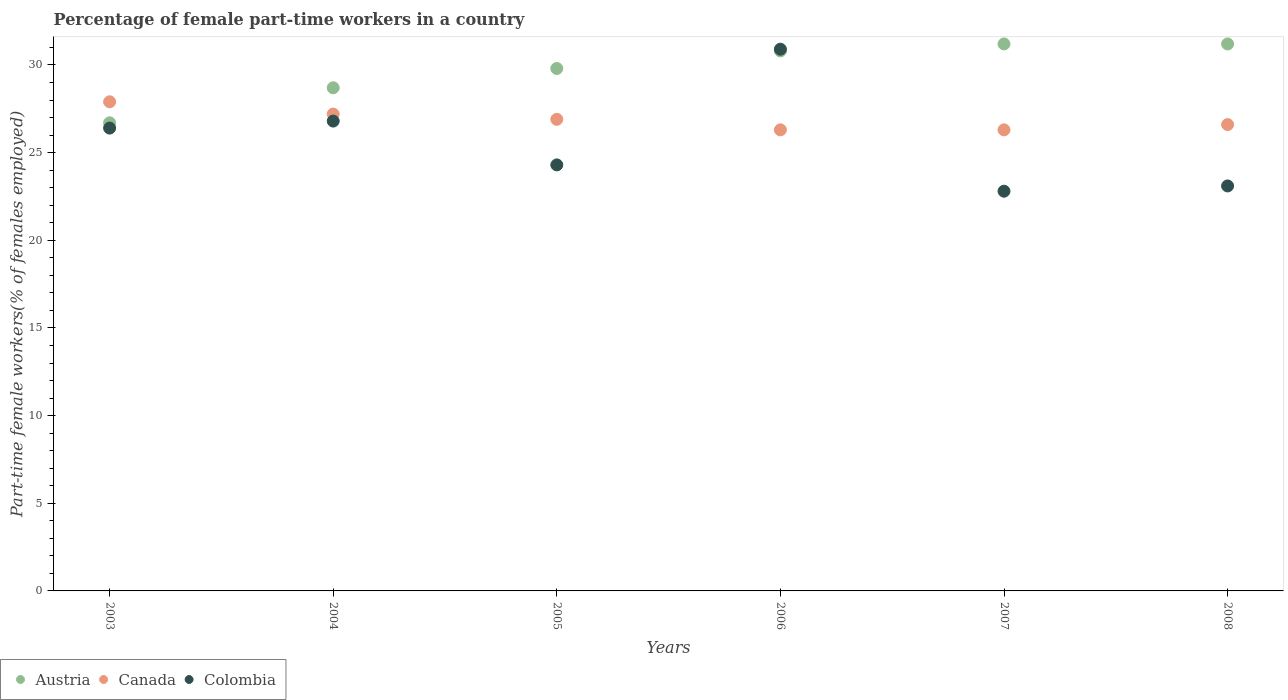How many different coloured dotlines are there?
Your response must be concise. 3. Is the number of dotlines equal to the number of legend labels?
Offer a very short reply. Yes. What is the percentage of female part-time workers in Canada in 2008?
Ensure brevity in your answer.  26.6. Across all years, what is the maximum percentage of female part-time workers in Colombia?
Offer a terse response. 30.9. Across all years, what is the minimum percentage of female part-time workers in Canada?
Give a very brief answer. 26.3. In which year was the percentage of female part-time workers in Canada maximum?
Provide a succinct answer. 2003. In which year was the percentage of female part-time workers in Canada minimum?
Provide a succinct answer. 2006. What is the total percentage of female part-time workers in Canada in the graph?
Give a very brief answer. 161.2. What is the difference between the percentage of female part-time workers in Austria in 2007 and that in 2008?
Give a very brief answer. 0. What is the difference between the percentage of female part-time workers in Austria in 2003 and the percentage of female part-time workers in Colombia in 2005?
Offer a terse response. 2.4. What is the average percentage of female part-time workers in Canada per year?
Provide a short and direct response. 26.87. In the year 2003, what is the difference between the percentage of female part-time workers in Canada and percentage of female part-time workers in Austria?
Keep it short and to the point. 1.2. What is the ratio of the percentage of female part-time workers in Colombia in 2004 to that in 2008?
Make the answer very short. 1.16. What is the difference between the highest and the second highest percentage of female part-time workers in Austria?
Give a very brief answer. 0. What is the difference between the highest and the lowest percentage of female part-time workers in Canada?
Provide a short and direct response. 1.6. In how many years, is the percentage of female part-time workers in Colombia greater than the average percentage of female part-time workers in Colombia taken over all years?
Ensure brevity in your answer.  3. How many dotlines are there?
Your answer should be very brief. 3. What is the difference between two consecutive major ticks on the Y-axis?
Provide a short and direct response. 5. Are the values on the major ticks of Y-axis written in scientific E-notation?
Offer a very short reply. No. What is the title of the graph?
Your answer should be compact. Percentage of female part-time workers in a country. What is the label or title of the Y-axis?
Provide a short and direct response. Part-time female workers(% of females employed). What is the Part-time female workers(% of females employed) of Austria in 2003?
Give a very brief answer. 26.7. What is the Part-time female workers(% of females employed) in Canada in 2003?
Keep it short and to the point. 27.9. What is the Part-time female workers(% of females employed) in Colombia in 2003?
Offer a terse response. 26.4. What is the Part-time female workers(% of females employed) in Austria in 2004?
Offer a very short reply. 28.7. What is the Part-time female workers(% of females employed) of Canada in 2004?
Your answer should be compact. 27.2. What is the Part-time female workers(% of females employed) of Colombia in 2004?
Offer a very short reply. 26.8. What is the Part-time female workers(% of females employed) of Austria in 2005?
Offer a terse response. 29.8. What is the Part-time female workers(% of females employed) in Canada in 2005?
Your answer should be very brief. 26.9. What is the Part-time female workers(% of females employed) in Colombia in 2005?
Your answer should be compact. 24.3. What is the Part-time female workers(% of females employed) of Austria in 2006?
Give a very brief answer. 30.8. What is the Part-time female workers(% of females employed) in Canada in 2006?
Provide a short and direct response. 26.3. What is the Part-time female workers(% of females employed) of Colombia in 2006?
Make the answer very short. 30.9. What is the Part-time female workers(% of females employed) of Austria in 2007?
Your answer should be compact. 31.2. What is the Part-time female workers(% of females employed) of Canada in 2007?
Your answer should be very brief. 26.3. What is the Part-time female workers(% of females employed) in Colombia in 2007?
Provide a succinct answer. 22.8. What is the Part-time female workers(% of females employed) in Austria in 2008?
Offer a very short reply. 31.2. What is the Part-time female workers(% of females employed) of Canada in 2008?
Provide a short and direct response. 26.6. What is the Part-time female workers(% of females employed) in Colombia in 2008?
Make the answer very short. 23.1. Across all years, what is the maximum Part-time female workers(% of females employed) in Austria?
Provide a succinct answer. 31.2. Across all years, what is the maximum Part-time female workers(% of females employed) of Canada?
Keep it short and to the point. 27.9. Across all years, what is the maximum Part-time female workers(% of females employed) of Colombia?
Provide a succinct answer. 30.9. Across all years, what is the minimum Part-time female workers(% of females employed) in Austria?
Your answer should be very brief. 26.7. Across all years, what is the minimum Part-time female workers(% of females employed) of Canada?
Your answer should be compact. 26.3. Across all years, what is the minimum Part-time female workers(% of females employed) of Colombia?
Provide a short and direct response. 22.8. What is the total Part-time female workers(% of females employed) of Austria in the graph?
Provide a short and direct response. 178.4. What is the total Part-time female workers(% of females employed) of Canada in the graph?
Provide a short and direct response. 161.2. What is the total Part-time female workers(% of females employed) of Colombia in the graph?
Your response must be concise. 154.3. What is the difference between the Part-time female workers(% of females employed) of Colombia in 2003 and that in 2004?
Your answer should be very brief. -0.4. What is the difference between the Part-time female workers(% of females employed) of Canada in 2003 and that in 2005?
Provide a succinct answer. 1. What is the difference between the Part-time female workers(% of females employed) of Colombia in 2003 and that in 2005?
Keep it short and to the point. 2.1. What is the difference between the Part-time female workers(% of females employed) in Austria in 2003 and that in 2006?
Your answer should be very brief. -4.1. What is the difference between the Part-time female workers(% of females employed) of Canada in 2003 and that in 2006?
Provide a succinct answer. 1.6. What is the difference between the Part-time female workers(% of females employed) in Colombia in 2003 and that in 2006?
Offer a terse response. -4.5. What is the difference between the Part-time female workers(% of females employed) in Austria in 2003 and that in 2007?
Keep it short and to the point. -4.5. What is the difference between the Part-time female workers(% of females employed) of Colombia in 2003 and that in 2007?
Your answer should be very brief. 3.6. What is the difference between the Part-time female workers(% of females employed) of Canada in 2003 and that in 2008?
Your answer should be compact. 1.3. What is the difference between the Part-time female workers(% of females employed) in Colombia in 2003 and that in 2008?
Offer a very short reply. 3.3. What is the difference between the Part-time female workers(% of females employed) in Austria in 2004 and that in 2005?
Offer a very short reply. -1.1. What is the difference between the Part-time female workers(% of females employed) in Colombia in 2004 and that in 2005?
Your answer should be very brief. 2.5. What is the difference between the Part-time female workers(% of females employed) of Colombia in 2004 and that in 2006?
Your answer should be very brief. -4.1. What is the difference between the Part-time female workers(% of females employed) in Canada in 2004 and that in 2007?
Your response must be concise. 0.9. What is the difference between the Part-time female workers(% of females employed) of Austria in 2004 and that in 2008?
Your response must be concise. -2.5. What is the difference between the Part-time female workers(% of females employed) of Colombia in 2004 and that in 2008?
Ensure brevity in your answer.  3.7. What is the difference between the Part-time female workers(% of females employed) in Canada in 2005 and that in 2006?
Offer a terse response. 0.6. What is the difference between the Part-time female workers(% of females employed) of Colombia in 2005 and that in 2006?
Keep it short and to the point. -6.6. What is the difference between the Part-time female workers(% of females employed) in Austria in 2005 and that in 2007?
Ensure brevity in your answer.  -1.4. What is the difference between the Part-time female workers(% of females employed) in Colombia in 2005 and that in 2007?
Your answer should be compact. 1.5. What is the difference between the Part-time female workers(% of females employed) of Austria in 2005 and that in 2008?
Provide a succinct answer. -1.4. What is the difference between the Part-time female workers(% of females employed) in Colombia in 2005 and that in 2008?
Your answer should be compact. 1.2. What is the difference between the Part-time female workers(% of females employed) of Canada in 2006 and that in 2008?
Offer a very short reply. -0.3. What is the difference between the Part-time female workers(% of females employed) of Colombia in 2006 and that in 2008?
Your answer should be compact. 7.8. What is the difference between the Part-time female workers(% of females employed) of Austria in 2007 and that in 2008?
Offer a very short reply. 0. What is the difference between the Part-time female workers(% of females employed) of Canada in 2007 and that in 2008?
Your response must be concise. -0.3. What is the difference between the Part-time female workers(% of females employed) in Colombia in 2007 and that in 2008?
Keep it short and to the point. -0.3. What is the difference between the Part-time female workers(% of females employed) in Austria in 2003 and the Part-time female workers(% of females employed) in Canada in 2004?
Provide a short and direct response. -0.5. What is the difference between the Part-time female workers(% of females employed) in Canada in 2003 and the Part-time female workers(% of females employed) in Colombia in 2004?
Make the answer very short. 1.1. What is the difference between the Part-time female workers(% of females employed) in Austria in 2003 and the Part-time female workers(% of females employed) in Canada in 2005?
Keep it short and to the point. -0.2. What is the difference between the Part-time female workers(% of females employed) of Austria in 2003 and the Part-time female workers(% of females employed) of Colombia in 2005?
Your answer should be very brief. 2.4. What is the difference between the Part-time female workers(% of females employed) of Canada in 2003 and the Part-time female workers(% of females employed) of Colombia in 2005?
Your answer should be compact. 3.6. What is the difference between the Part-time female workers(% of females employed) of Austria in 2003 and the Part-time female workers(% of females employed) of Canada in 2006?
Offer a terse response. 0.4. What is the difference between the Part-time female workers(% of females employed) of Austria in 2003 and the Part-time female workers(% of females employed) of Canada in 2008?
Offer a terse response. 0.1. What is the difference between the Part-time female workers(% of females employed) of Austria in 2003 and the Part-time female workers(% of females employed) of Colombia in 2008?
Provide a short and direct response. 3.6. What is the difference between the Part-time female workers(% of females employed) of Austria in 2004 and the Part-time female workers(% of females employed) of Canada in 2005?
Your answer should be very brief. 1.8. What is the difference between the Part-time female workers(% of females employed) in Canada in 2004 and the Part-time female workers(% of females employed) in Colombia in 2006?
Keep it short and to the point. -3.7. What is the difference between the Part-time female workers(% of females employed) of Austria in 2004 and the Part-time female workers(% of females employed) of Colombia in 2007?
Provide a short and direct response. 5.9. What is the difference between the Part-time female workers(% of females employed) in Austria in 2005 and the Part-time female workers(% of females employed) in Colombia in 2006?
Give a very brief answer. -1.1. What is the difference between the Part-time female workers(% of females employed) of Canada in 2005 and the Part-time female workers(% of females employed) of Colombia in 2006?
Make the answer very short. -4. What is the difference between the Part-time female workers(% of females employed) in Austria in 2005 and the Part-time female workers(% of females employed) in Colombia in 2007?
Your answer should be compact. 7. What is the difference between the Part-time female workers(% of females employed) in Austria in 2005 and the Part-time female workers(% of females employed) in Canada in 2008?
Offer a very short reply. 3.2. What is the difference between the Part-time female workers(% of females employed) in Austria in 2005 and the Part-time female workers(% of females employed) in Colombia in 2008?
Ensure brevity in your answer.  6.7. What is the difference between the Part-time female workers(% of females employed) in Canada in 2005 and the Part-time female workers(% of females employed) in Colombia in 2008?
Keep it short and to the point. 3.8. What is the difference between the Part-time female workers(% of females employed) of Canada in 2006 and the Part-time female workers(% of females employed) of Colombia in 2007?
Keep it short and to the point. 3.5. What is the difference between the Part-time female workers(% of females employed) of Austria in 2006 and the Part-time female workers(% of females employed) of Colombia in 2008?
Ensure brevity in your answer.  7.7. What is the average Part-time female workers(% of females employed) in Austria per year?
Provide a short and direct response. 29.73. What is the average Part-time female workers(% of females employed) of Canada per year?
Give a very brief answer. 26.87. What is the average Part-time female workers(% of females employed) in Colombia per year?
Offer a very short reply. 25.72. In the year 2003, what is the difference between the Part-time female workers(% of females employed) in Austria and Part-time female workers(% of females employed) in Canada?
Provide a short and direct response. -1.2. In the year 2004, what is the difference between the Part-time female workers(% of females employed) of Austria and Part-time female workers(% of females employed) of Canada?
Keep it short and to the point. 1.5. In the year 2004, what is the difference between the Part-time female workers(% of females employed) of Austria and Part-time female workers(% of females employed) of Colombia?
Give a very brief answer. 1.9. In the year 2005, what is the difference between the Part-time female workers(% of females employed) of Austria and Part-time female workers(% of females employed) of Canada?
Make the answer very short. 2.9. In the year 2005, what is the difference between the Part-time female workers(% of females employed) of Austria and Part-time female workers(% of females employed) of Colombia?
Your answer should be very brief. 5.5. In the year 2006, what is the difference between the Part-time female workers(% of females employed) of Austria and Part-time female workers(% of females employed) of Canada?
Keep it short and to the point. 4.5. In the year 2007, what is the difference between the Part-time female workers(% of females employed) of Austria and Part-time female workers(% of females employed) of Canada?
Ensure brevity in your answer.  4.9. In the year 2007, what is the difference between the Part-time female workers(% of females employed) in Austria and Part-time female workers(% of females employed) in Colombia?
Your answer should be very brief. 8.4. In the year 2008, what is the difference between the Part-time female workers(% of females employed) in Austria and Part-time female workers(% of females employed) in Canada?
Keep it short and to the point. 4.6. What is the ratio of the Part-time female workers(% of females employed) of Austria in 2003 to that in 2004?
Offer a terse response. 0.93. What is the ratio of the Part-time female workers(% of females employed) in Canada in 2003 to that in 2004?
Ensure brevity in your answer.  1.03. What is the ratio of the Part-time female workers(% of females employed) of Colombia in 2003 to that in 2004?
Give a very brief answer. 0.99. What is the ratio of the Part-time female workers(% of females employed) of Austria in 2003 to that in 2005?
Provide a succinct answer. 0.9. What is the ratio of the Part-time female workers(% of females employed) in Canada in 2003 to that in 2005?
Make the answer very short. 1.04. What is the ratio of the Part-time female workers(% of females employed) of Colombia in 2003 to that in 2005?
Provide a short and direct response. 1.09. What is the ratio of the Part-time female workers(% of females employed) of Austria in 2003 to that in 2006?
Offer a very short reply. 0.87. What is the ratio of the Part-time female workers(% of females employed) in Canada in 2003 to that in 2006?
Your response must be concise. 1.06. What is the ratio of the Part-time female workers(% of females employed) of Colombia in 2003 to that in 2006?
Ensure brevity in your answer.  0.85. What is the ratio of the Part-time female workers(% of females employed) in Austria in 2003 to that in 2007?
Ensure brevity in your answer.  0.86. What is the ratio of the Part-time female workers(% of females employed) of Canada in 2003 to that in 2007?
Your response must be concise. 1.06. What is the ratio of the Part-time female workers(% of females employed) of Colombia in 2003 to that in 2007?
Keep it short and to the point. 1.16. What is the ratio of the Part-time female workers(% of females employed) in Austria in 2003 to that in 2008?
Offer a very short reply. 0.86. What is the ratio of the Part-time female workers(% of females employed) in Canada in 2003 to that in 2008?
Keep it short and to the point. 1.05. What is the ratio of the Part-time female workers(% of females employed) of Austria in 2004 to that in 2005?
Make the answer very short. 0.96. What is the ratio of the Part-time female workers(% of females employed) in Canada in 2004 to that in 2005?
Ensure brevity in your answer.  1.01. What is the ratio of the Part-time female workers(% of females employed) of Colombia in 2004 to that in 2005?
Make the answer very short. 1.1. What is the ratio of the Part-time female workers(% of females employed) of Austria in 2004 to that in 2006?
Provide a short and direct response. 0.93. What is the ratio of the Part-time female workers(% of females employed) of Canada in 2004 to that in 2006?
Your answer should be compact. 1.03. What is the ratio of the Part-time female workers(% of females employed) in Colombia in 2004 to that in 2006?
Give a very brief answer. 0.87. What is the ratio of the Part-time female workers(% of females employed) in Austria in 2004 to that in 2007?
Ensure brevity in your answer.  0.92. What is the ratio of the Part-time female workers(% of females employed) of Canada in 2004 to that in 2007?
Your response must be concise. 1.03. What is the ratio of the Part-time female workers(% of females employed) of Colombia in 2004 to that in 2007?
Your answer should be very brief. 1.18. What is the ratio of the Part-time female workers(% of females employed) of Austria in 2004 to that in 2008?
Make the answer very short. 0.92. What is the ratio of the Part-time female workers(% of females employed) of Canada in 2004 to that in 2008?
Your answer should be compact. 1.02. What is the ratio of the Part-time female workers(% of females employed) of Colombia in 2004 to that in 2008?
Provide a succinct answer. 1.16. What is the ratio of the Part-time female workers(% of females employed) of Austria in 2005 to that in 2006?
Give a very brief answer. 0.97. What is the ratio of the Part-time female workers(% of females employed) in Canada in 2005 to that in 2006?
Provide a short and direct response. 1.02. What is the ratio of the Part-time female workers(% of females employed) of Colombia in 2005 to that in 2006?
Give a very brief answer. 0.79. What is the ratio of the Part-time female workers(% of females employed) of Austria in 2005 to that in 2007?
Your answer should be compact. 0.96. What is the ratio of the Part-time female workers(% of females employed) of Canada in 2005 to that in 2007?
Provide a succinct answer. 1.02. What is the ratio of the Part-time female workers(% of females employed) in Colombia in 2005 to that in 2007?
Your answer should be very brief. 1.07. What is the ratio of the Part-time female workers(% of females employed) of Austria in 2005 to that in 2008?
Provide a short and direct response. 0.96. What is the ratio of the Part-time female workers(% of females employed) in Canada in 2005 to that in 2008?
Provide a succinct answer. 1.01. What is the ratio of the Part-time female workers(% of females employed) in Colombia in 2005 to that in 2008?
Make the answer very short. 1.05. What is the ratio of the Part-time female workers(% of females employed) of Austria in 2006 to that in 2007?
Make the answer very short. 0.99. What is the ratio of the Part-time female workers(% of females employed) in Colombia in 2006 to that in 2007?
Your answer should be very brief. 1.36. What is the ratio of the Part-time female workers(% of females employed) of Austria in 2006 to that in 2008?
Your answer should be very brief. 0.99. What is the ratio of the Part-time female workers(% of females employed) of Canada in 2006 to that in 2008?
Provide a short and direct response. 0.99. What is the ratio of the Part-time female workers(% of females employed) in Colombia in 2006 to that in 2008?
Your response must be concise. 1.34. What is the ratio of the Part-time female workers(% of females employed) of Austria in 2007 to that in 2008?
Your answer should be very brief. 1. What is the ratio of the Part-time female workers(% of females employed) of Canada in 2007 to that in 2008?
Ensure brevity in your answer.  0.99. What is the difference between the highest and the lowest Part-time female workers(% of females employed) in Austria?
Keep it short and to the point. 4.5. What is the difference between the highest and the lowest Part-time female workers(% of females employed) in Colombia?
Keep it short and to the point. 8.1. 